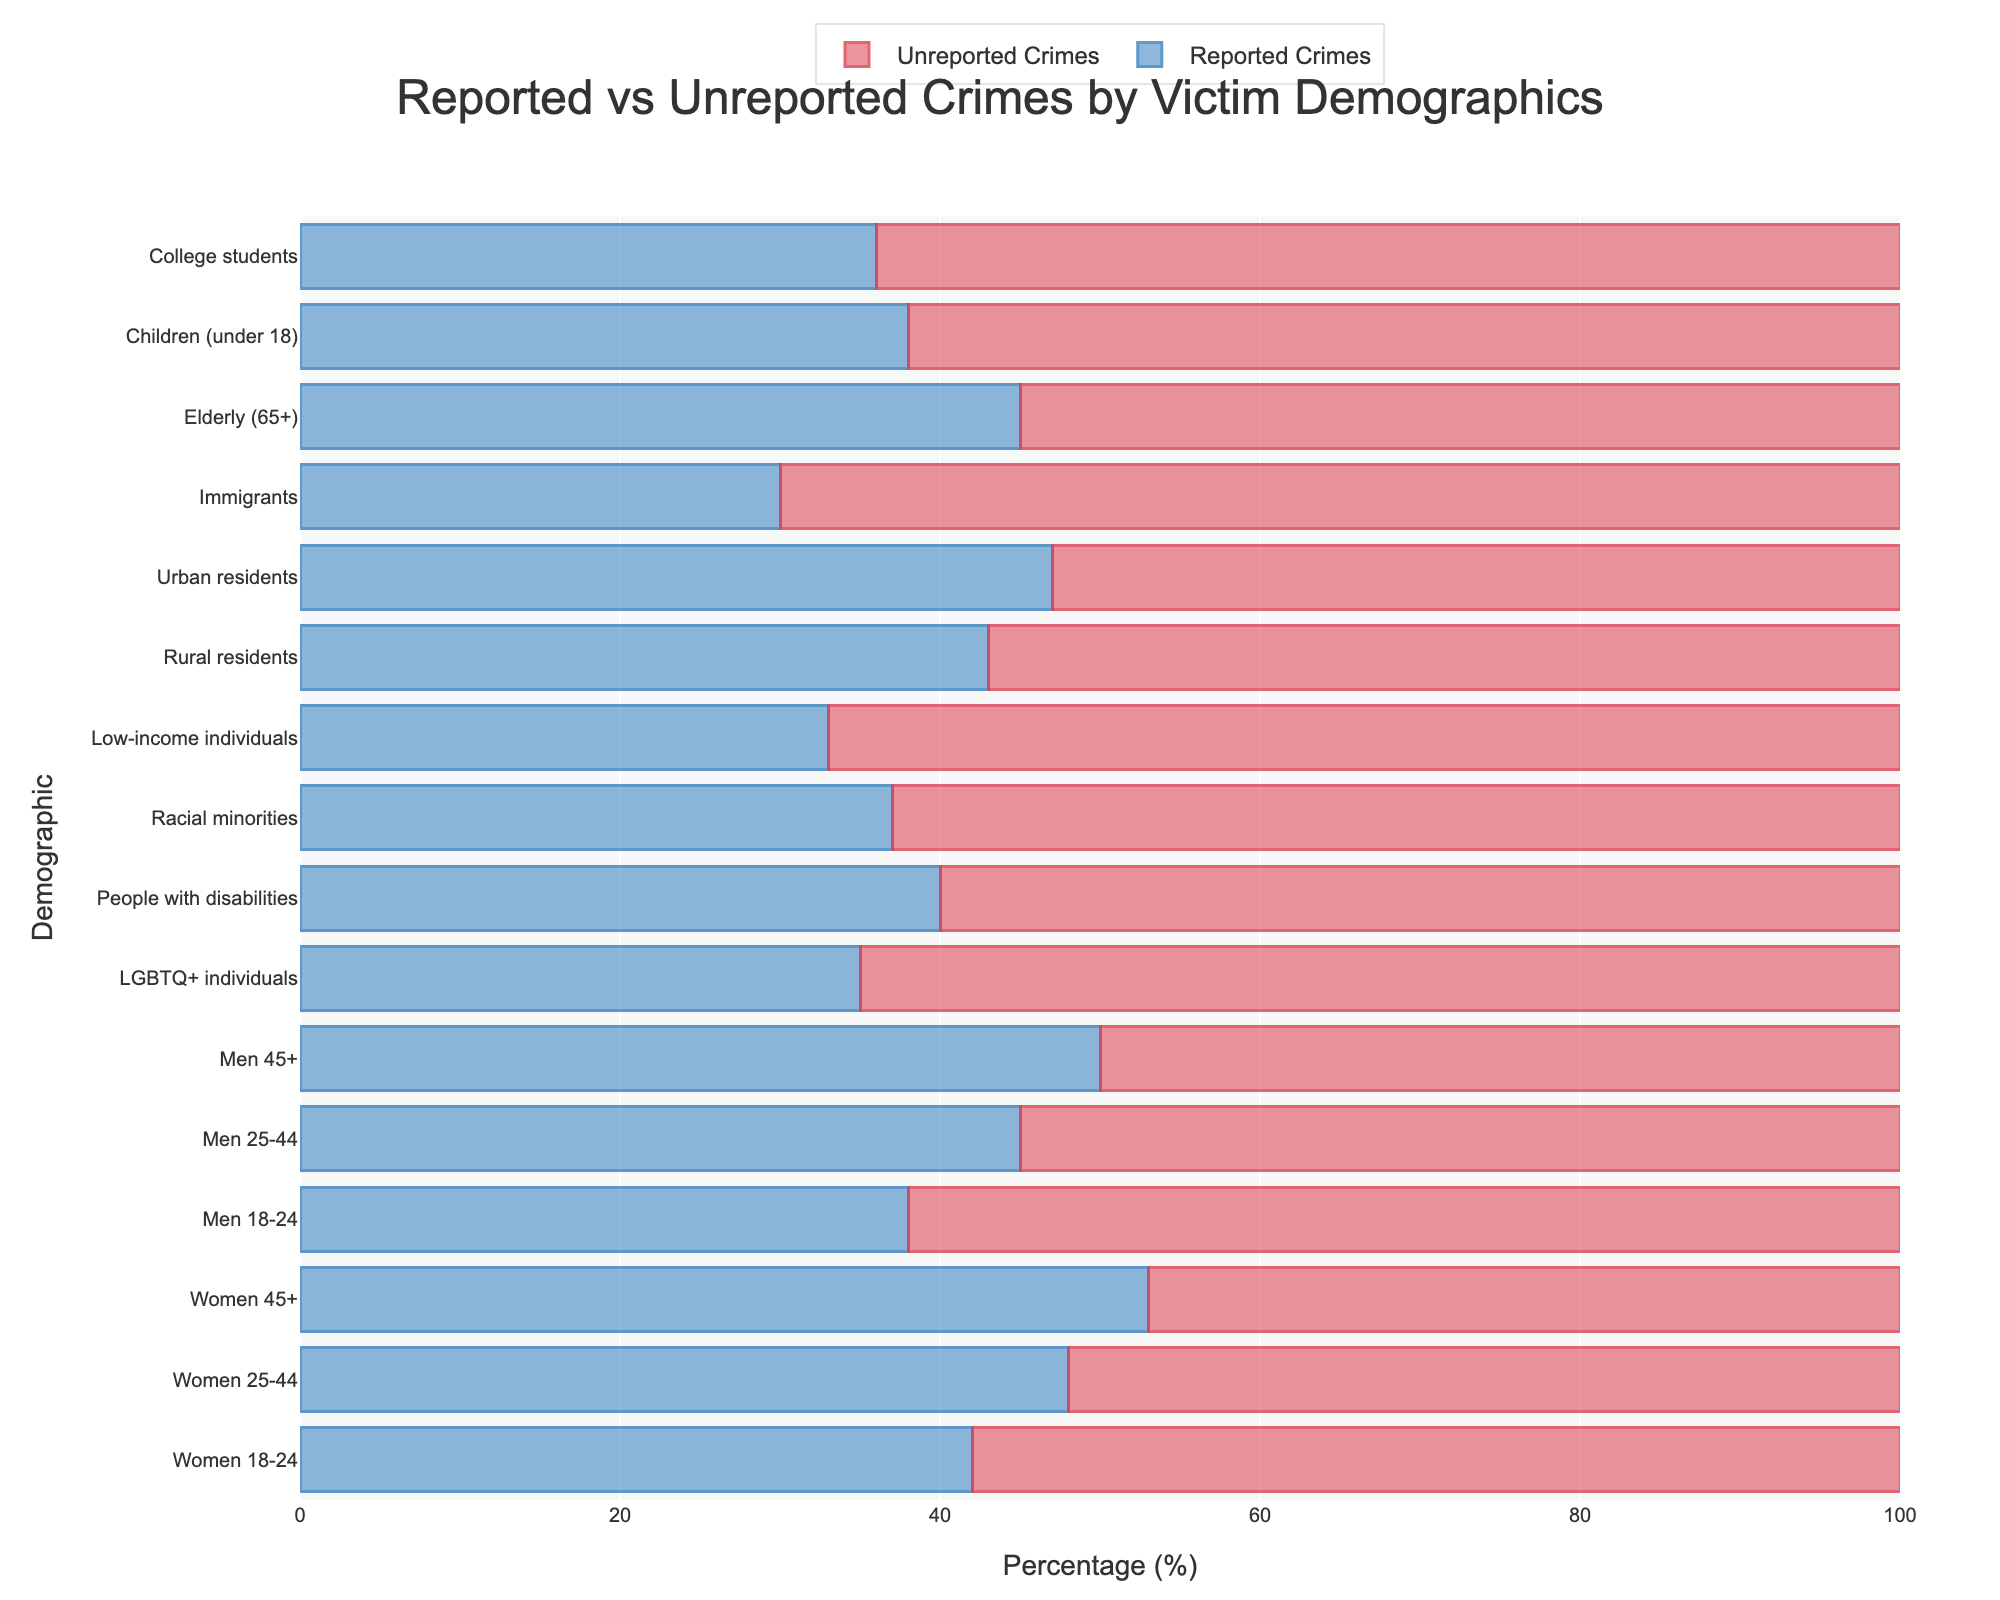Which demographic has the highest percentage of unreported crimes? The figure visually represents the percentage of reported and unreported crimes for each demographic. By examining the lengths of the red bars, the longest corresponds to "Immigrants" with 70% unreported crimes.
Answer: Immigrants What is the difference in reported crime percentages between "Women 25-44" and "Men 25-44"? From the figure, "Women 25-44" have 48% reported crimes, and "Men 25-44" have 45%. The difference is 48% - 45%.
Answer: 3% Which demographic group has an equal percentage of reported and unreported crimes? A visual scan of the chart reveals that "Men 45+" have 50% reported and 50% unreported crimes, indicating equality.
Answer: Men 45+ What is the average percentage of unreported crimes among "Racial minorities" and "LGBTQ+ individuals"? "Racial minorities" have 63% unreported crimes, while "LGBTQ+ individuals" have 65%. The average is (63 + 65) / 2.
Answer: 64% Compare the reported crime percentage for "Children (under 18)" and "College students". Which group reports more crimes? "Children (under 18)" have 38% reported crimes, and "College students" have 36%. Children (under 18) have a higher reported crime percentage.
Answer: Children (under 18) What is the combined percentage of unreported crimes for "Low-income individuals" and "Rural residents"? "Low-income individuals" have 67% unreported crimes, and "Rural residents" have 57%. The combined percentage is 67 + 57.
Answer: 124% Which demographic reports more crimes: "People with disabilities" or "Racial minorities"? "People with disabilities" report 40% of crimes, while "Racial minorities" report 37%. Hence, "People with disabilities" report a higher percentage.
Answer: People with disabilities What is the ratio of unreported to reported crimes for "Elderly (65+)"? The unreported percentage for the "Elderly (65+)" is 55%, and the reported percentage is 45%. The ratio is 55/45.
Answer: 11:9 What is the median percentage of reported crimes across all demographics? Sorting the reported percentages: 30, 33, 35, 36, 38, 38, 40, 42, 43, 45, 45, 47, 48, 50, 53. The middle value (median) is 42.
Answer: 42% By what percentage do unreported crimes for "Men 18-24" exceed those for "Women 18-24"? "Men 18-24" have 62% unreported crimes, and "Women 18-24" have 58%. The excess percentage is 62 - 58.
Answer: 4% 